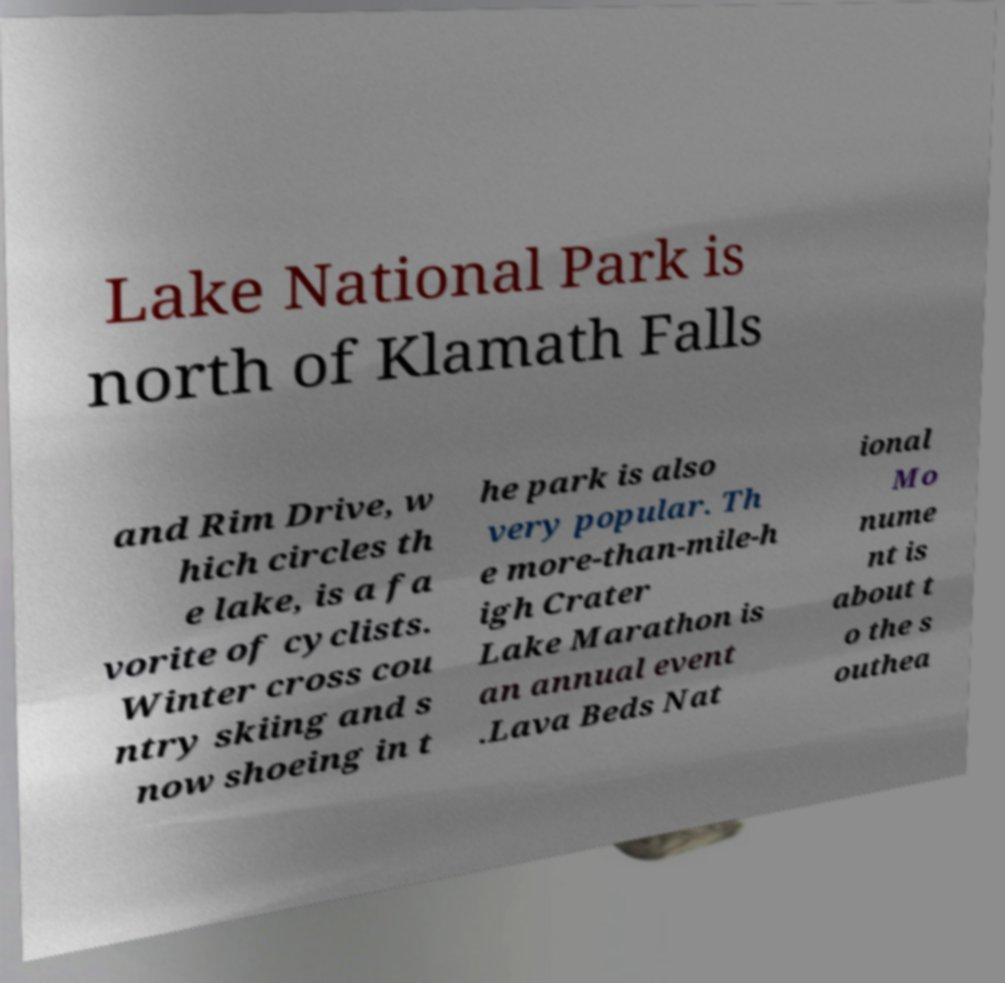What messages or text are displayed in this image? I need them in a readable, typed format. Lake National Park is north of Klamath Falls and Rim Drive, w hich circles th e lake, is a fa vorite of cyclists. Winter cross cou ntry skiing and s now shoeing in t he park is also very popular. Th e more-than-mile-h igh Crater Lake Marathon is an annual event .Lava Beds Nat ional Mo nume nt is about t o the s outhea 